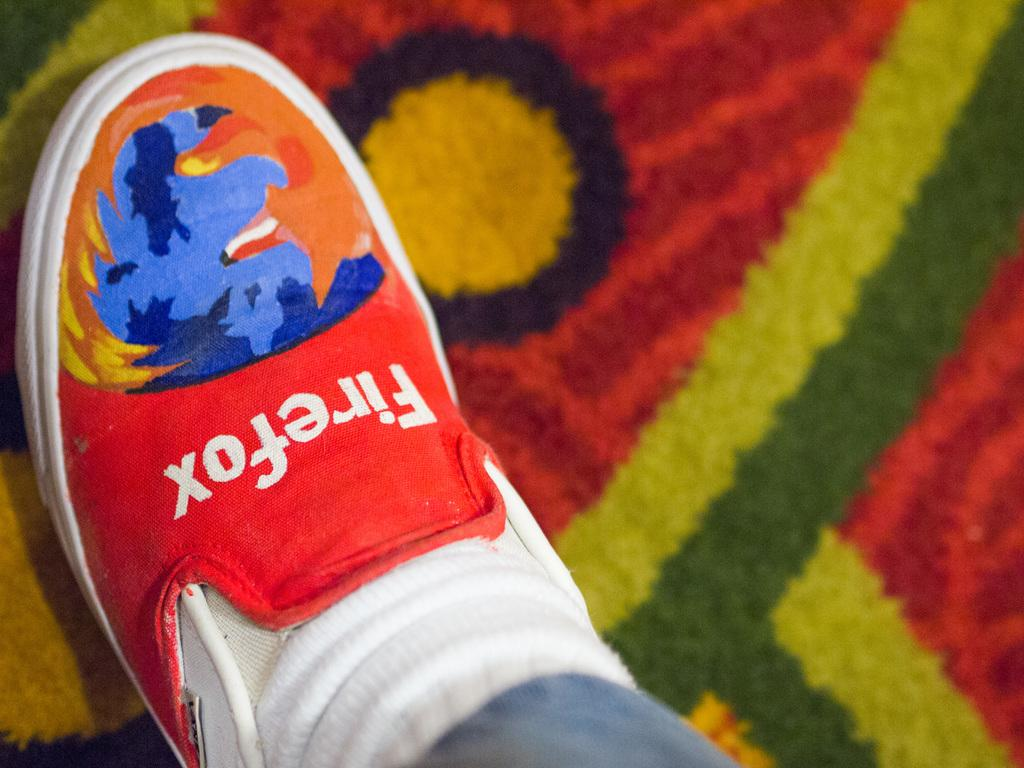What type of shoe is the focus of the image? The image is a zoomed-in picture of a person's Firefox shoe. Can you describe the background of the image? The background of the image is colorful. How many sheep are visible in the image? There are no sheep present in the image; it is a picture of a Firefox shoe. What type of disease is being treated in the image? There is no indication of a disease or treatment in the image; it is a picture of a Firefox shoe. 